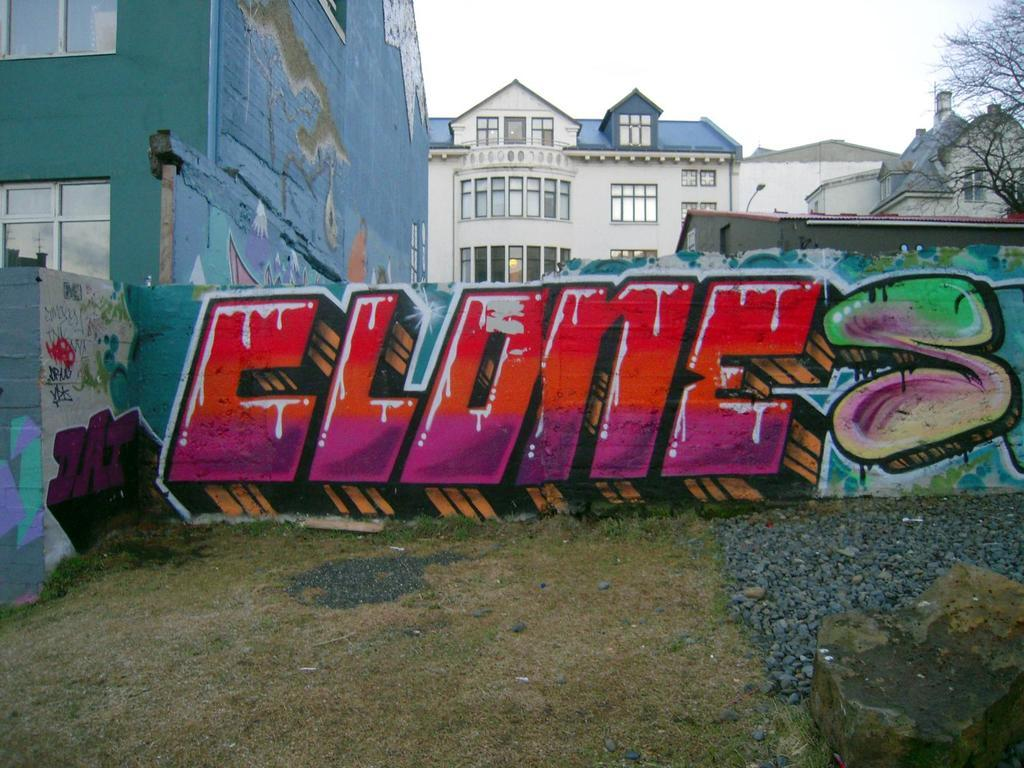What is depicted on the wall in the center of the image? There is graffiti on a wall in the center of the image. What type of vegetation can be seen at the bottom of the image? There is grass and stones at the bottom of the image. What can be seen in the background of the image? There are buildings, a tree, and the sky visible in the background of the image. What type of liquid can be seen flowing from the tree in the image? There is no liquid flowing from the tree in the image; it is a static image with no motion or liquid present. 